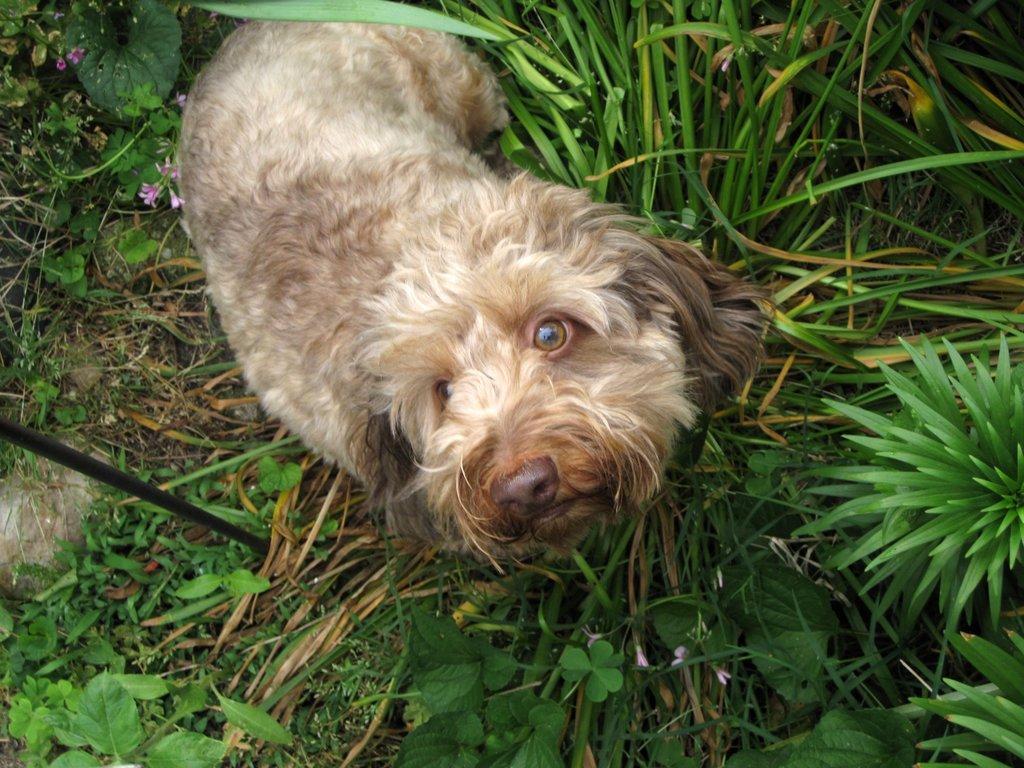In one or two sentences, can you explain what this image depicts? In this image I can see the grass and few plants on the ground and also there is a dog laying on the ground and looking at the picture. 